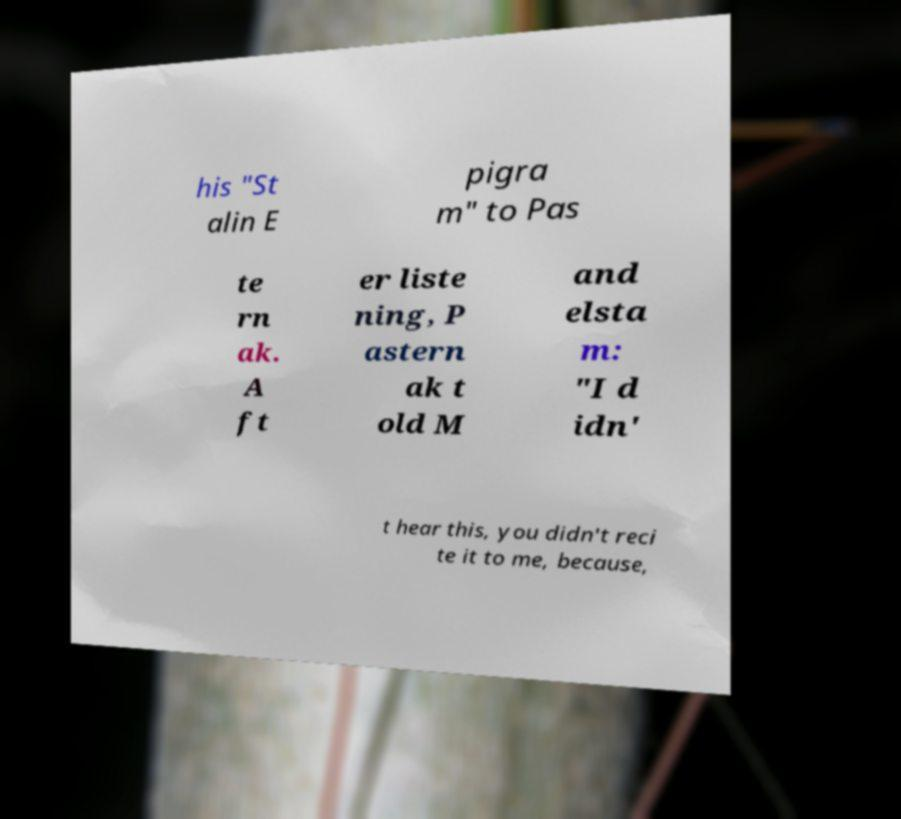Please identify and transcribe the text found in this image. his "St alin E pigra m" to Pas te rn ak. A ft er liste ning, P astern ak t old M and elsta m: "I d idn' t hear this, you didn't reci te it to me, because, 